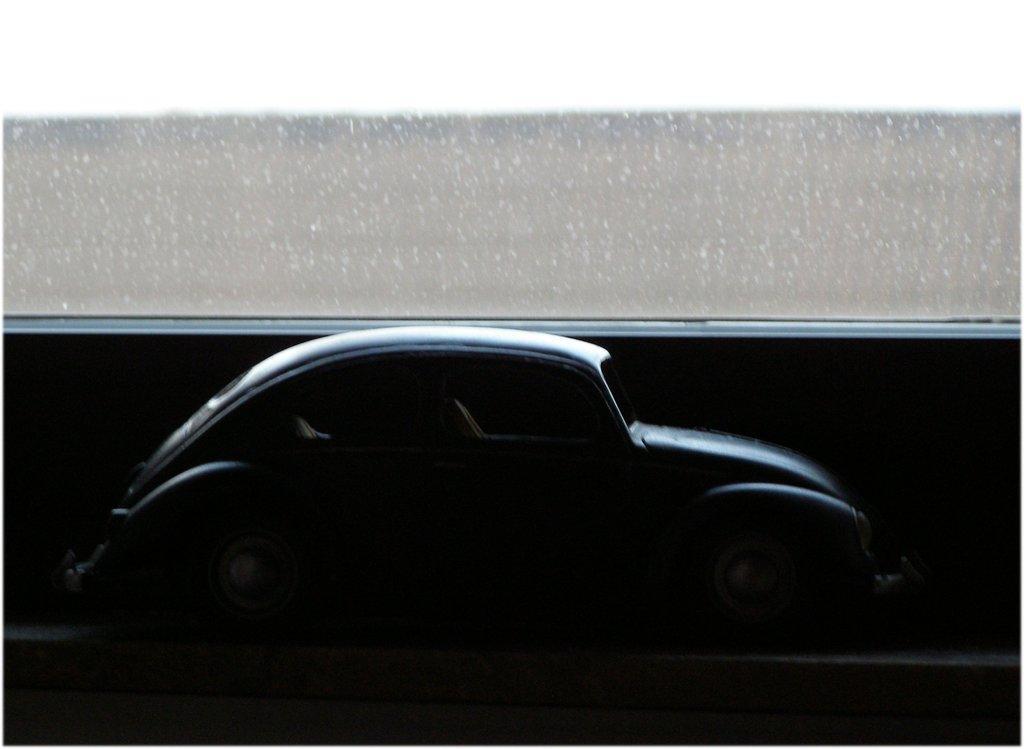In one or two sentences, can you explain what this image depicts? In this image we can see a toy car on a black surface. At the top we can see an object looks like a glass. 